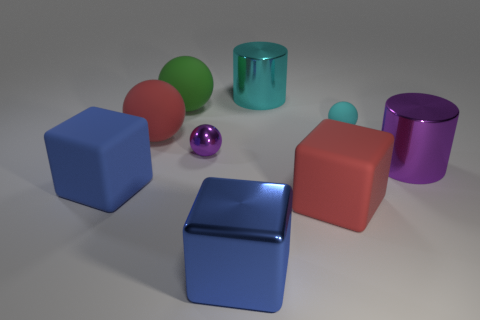What materials do you think each object in this image is made of and why do you think so? Starting from the left, the blue cube appears to be made of plastic due to its uniform color and slight reflections. The green sphere seems like it could also be plastic, given its smooth surface. The red sphere has a matte finish, suggesting a rubber composition. As for the cyan cylinder, its reflective surface indicates a metallic material. The purple cylinder shares a similar finish, pointing towards metal. Lastly, the small pink sphere looks metallic due to its size and high glossiness. 